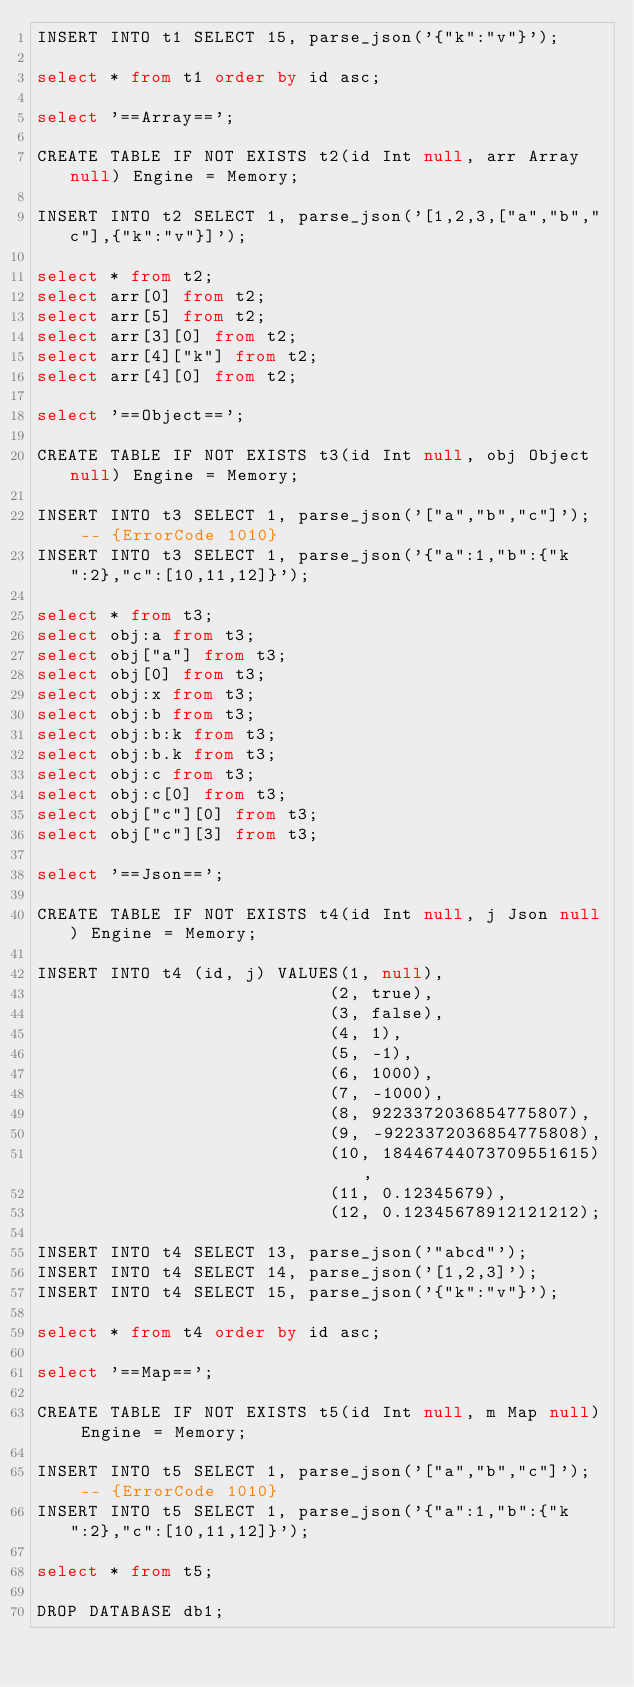Convert code to text. <code><loc_0><loc_0><loc_500><loc_500><_SQL_>INSERT INTO t1 SELECT 15, parse_json('{"k":"v"}');

select * from t1 order by id asc;

select '==Array==';

CREATE TABLE IF NOT EXISTS t2(id Int null, arr Array null) Engine = Memory;

INSERT INTO t2 SELECT 1, parse_json('[1,2,3,["a","b","c"],{"k":"v"}]');

select * from t2;
select arr[0] from t2;
select arr[5] from t2;
select arr[3][0] from t2;
select arr[4]["k"] from t2;
select arr[4][0] from t2;

select '==Object==';

CREATE TABLE IF NOT EXISTS t3(id Int null, obj Object null) Engine = Memory;

INSERT INTO t3 SELECT 1, parse_json('["a","b","c"]');  -- {ErrorCode 1010}
INSERT INTO t3 SELECT 1, parse_json('{"a":1,"b":{"k":2},"c":[10,11,12]}');

select * from t3;
select obj:a from t3;
select obj["a"] from t3;
select obj[0] from t3;
select obj:x from t3;
select obj:b from t3;
select obj:b:k from t3;
select obj:b.k from t3;
select obj:c from t3;
select obj:c[0] from t3;
select obj["c"][0] from t3;
select obj["c"][3] from t3;

select '==Json==';

CREATE TABLE IF NOT EXISTS t4(id Int null, j Json null) Engine = Memory;

INSERT INTO t4 (id, j) VALUES(1, null),
                            (2, true),
                            (3, false),
                            (4, 1),
                            (5, -1),
                            (6, 1000),
                            (7, -1000),
                            (8, 9223372036854775807),
                            (9, -9223372036854775808),
                            (10, 18446744073709551615),
                            (11, 0.12345679),
                            (12, 0.12345678912121212);

INSERT INTO t4 SELECT 13, parse_json('"abcd"');
INSERT INTO t4 SELECT 14, parse_json('[1,2,3]');
INSERT INTO t4 SELECT 15, parse_json('{"k":"v"}');

select * from t4 order by id asc;

select '==Map==';

CREATE TABLE IF NOT EXISTS t5(id Int null, m Map null) Engine = Memory;

INSERT INTO t5 SELECT 1, parse_json('["a","b","c"]');  -- {ErrorCode 1010}
INSERT INTO t5 SELECT 1, parse_json('{"a":1,"b":{"k":2},"c":[10,11,12]}');

select * from t5;

DROP DATABASE db1;
</code> 